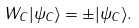<formula> <loc_0><loc_0><loc_500><loc_500>W _ { C } | \psi _ { C } \rangle = \pm | \psi _ { C } \rangle .</formula> 